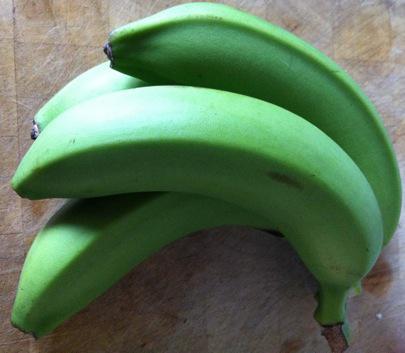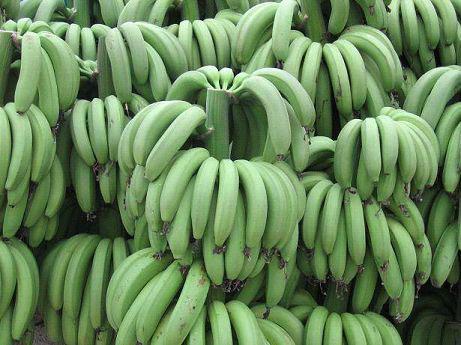The first image is the image on the left, the second image is the image on the right. Assess this claim about the two images: "There is an image with one bunch of unripe bananas, and another image with multiple bunches.". Correct or not? Answer yes or no. Yes. The first image is the image on the left, the second image is the image on the right. For the images shown, is this caption "One image includes only one small bunch of green bananas, with no more than five bananas visible." true? Answer yes or no. Yes. 